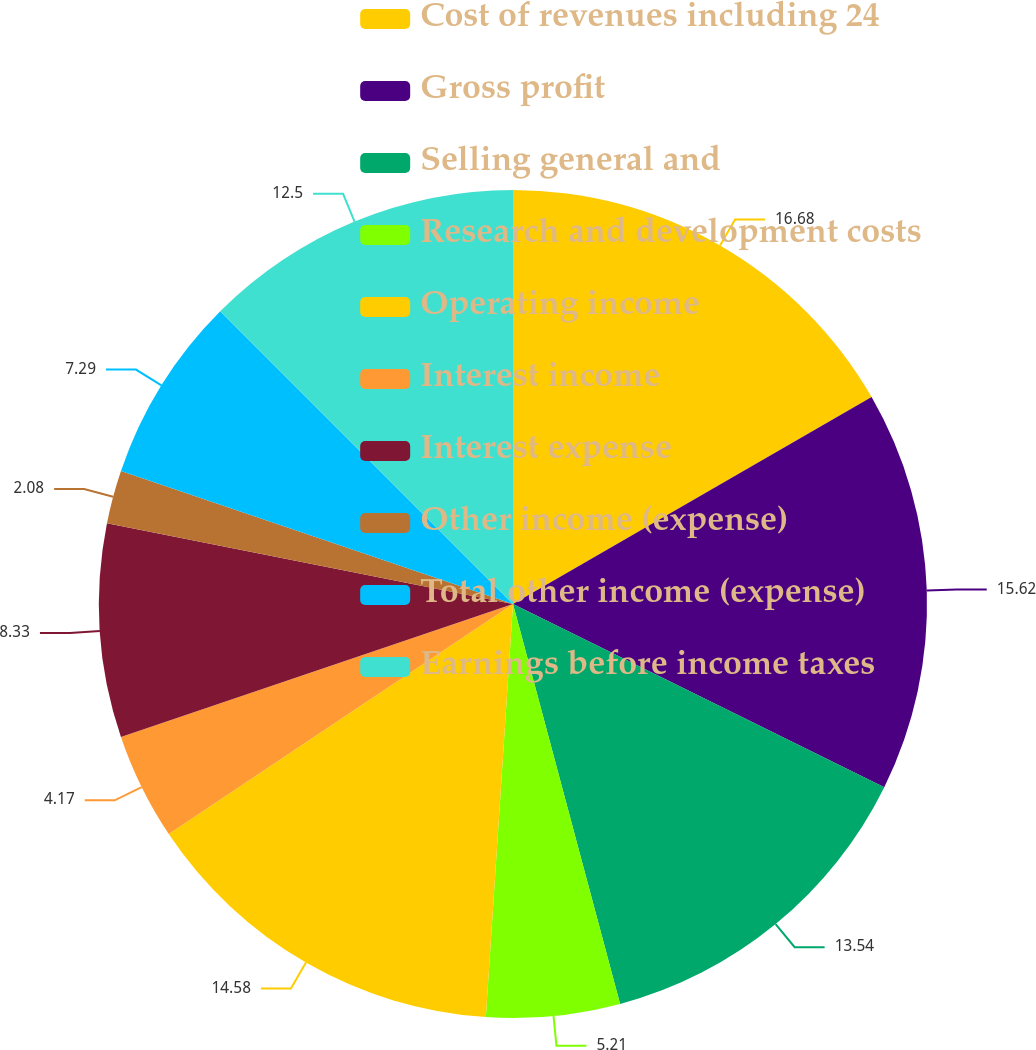Convert chart. <chart><loc_0><loc_0><loc_500><loc_500><pie_chart><fcel>Cost of revenues including 24<fcel>Gross profit<fcel>Selling general and<fcel>Research and development costs<fcel>Operating income<fcel>Interest income<fcel>Interest expense<fcel>Other income (expense)<fcel>Total other income (expense)<fcel>Earnings before income taxes<nl><fcel>16.67%<fcel>15.62%<fcel>13.54%<fcel>5.21%<fcel>14.58%<fcel>4.17%<fcel>8.33%<fcel>2.08%<fcel>7.29%<fcel>12.5%<nl></chart> 